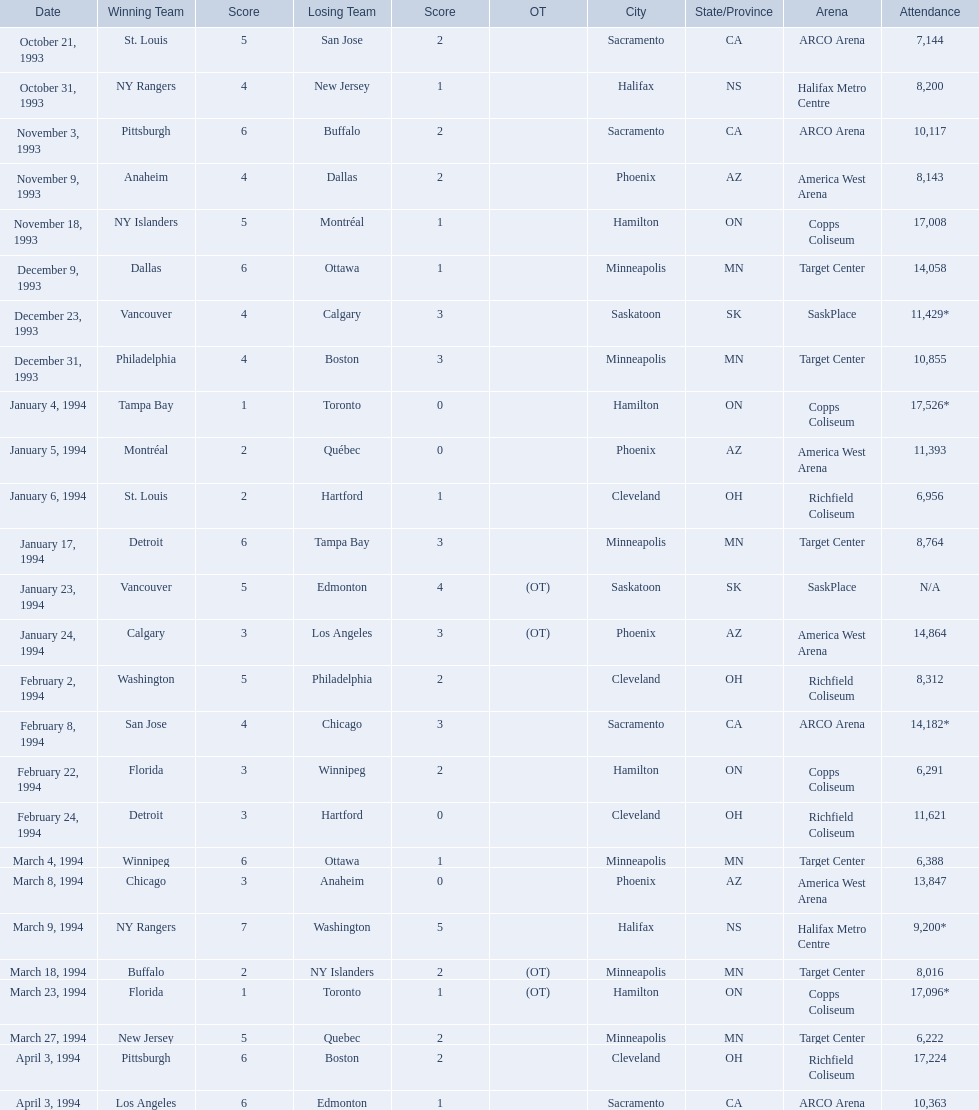What are the attendances of the 1993-94 nhl season? 7,144, 8,200, 10,117, 8,143, 17,008, 14,058, 11,429*, 10,855, 17,526*, 11,393, 6,956, 8,764, N/A, 14,864, 8,312, 14,182*, 6,291, 11,621, 6,388, 13,847, 9,200*, 8,016, 17,096*, 6,222, 17,224, 10,363. Which of these is the highest attendance? 17,526*. Which date did this attendance occur? January 4, 1994. 